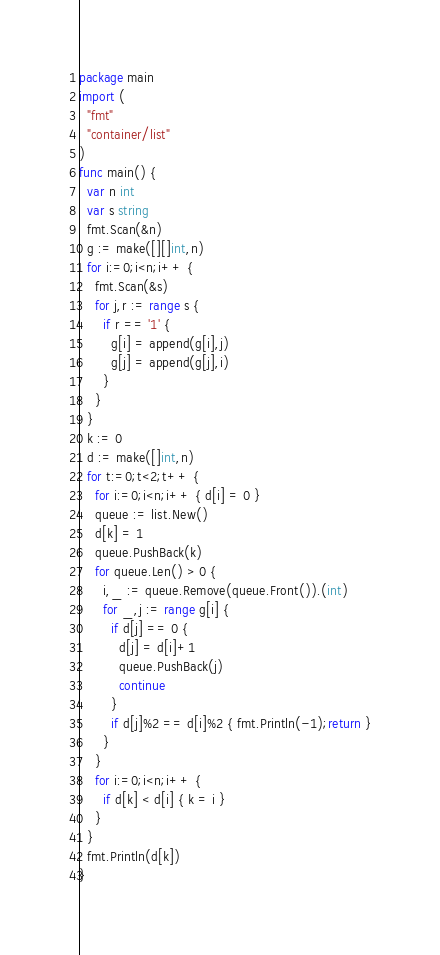Convert code to text. <code><loc_0><loc_0><loc_500><loc_500><_Go_>package main
import (
  "fmt"
  "container/list"
)
func main() {
  var n int
  var s string
  fmt.Scan(&n)
  g := make([][]int,n)
  for i:=0;i<n;i++ {
    fmt.Scan(&s)
    for j,r := range s {
      if r == '1' {
        g[i] = append(g[i],j)
        g[j] = append(g[j],i)
      }
    }
  }
  k := 0
  d := make([]int,n)
  for t:=0;t<2;t++ {
    for i:=0;i<n;i++ { d[i] = 0 }
    queue := list.New()
    d[k] = 1
    queue.PushBack(k)
    for queue.Len() > 0 {
      i,_ := queue.Remove(queue.Front()).(int)
      for _,j := range g[i] {
        if d[j] == 0 {
          d[j] = d[i]+1
          queue.PushBack(j)
          continue
        }
        if d[j]%2 == d[i]%2 { fmt.Println(-1);return }
      }
    }
    for i:=0;i<n;i++ {
      if d[k] < d[i] { k = i }
    }
  }
  fmt.Println(d[k])
}</code> 